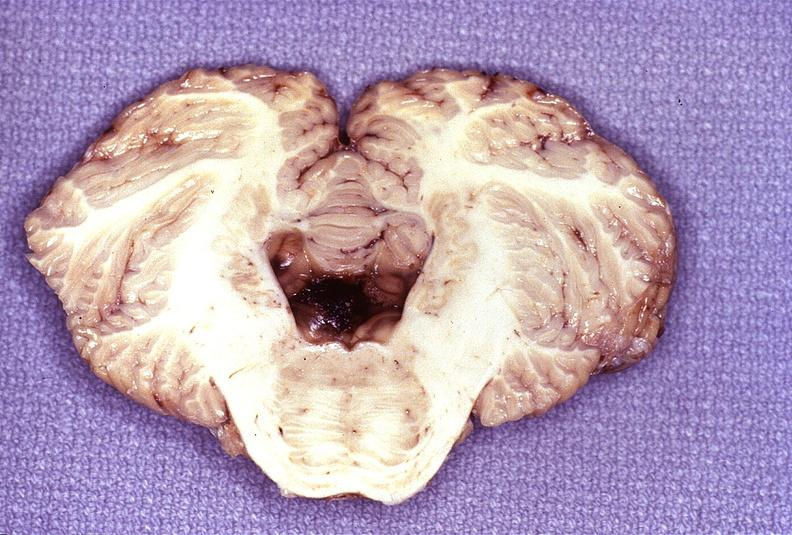what does this image show?
Answer the question using a single word or phrase. Wernicke 's encephalopathy 